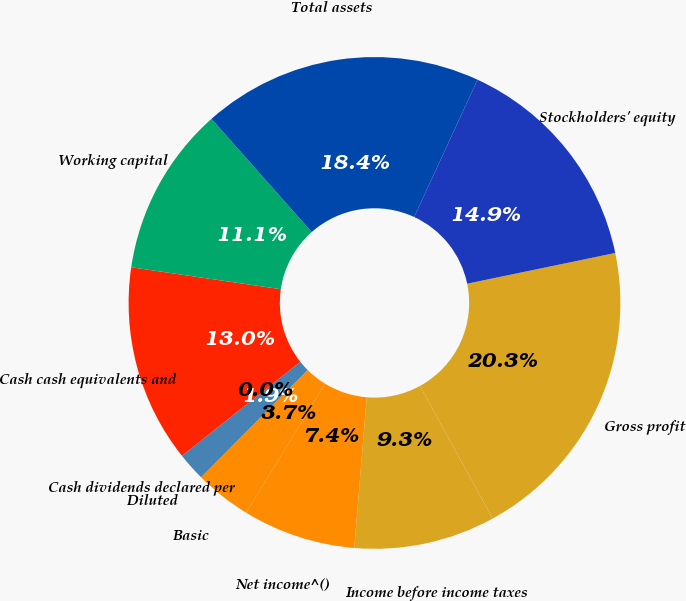Convert chart to OTSL. <chart><loc_0><loc_0><loc_500><loc_500><pie_chart><fcel>Gross profit<fcel>Income before income taxes<fcel>Net income^()<fcel>Basic<fcel>Diluted<fcel>Cash dividends declared per<fcel>Cash cash equivalents and<fcel>Working capital<fcel>Total assets<fcel>Stockholders' equity<nl><fcel>20.28%<fcel>9.29%<fcel>7.43%<fcel>3.72%<fcel>1.86%<fcel>0.0%<fcel>13.0%<fcel>11.15%<fcel>18.42%<fcel>14.86%<nl></chart> 